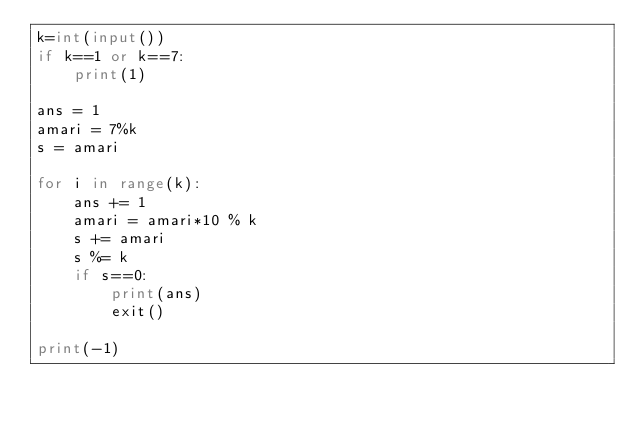Convert code to text. <code><loc_0><loc_0><loc_500><loc_500><_Python_>k=int(input())
if k==1 or k==7:
    print(1)

ans = 1
amari = 7%k
s = amari

for i in range(k):
    ans += 1
    amari = amari*10 % k
    s += amari
    s %= k
    if s==0:
        print(ans)
        exit()
    
print(-1)</code> 